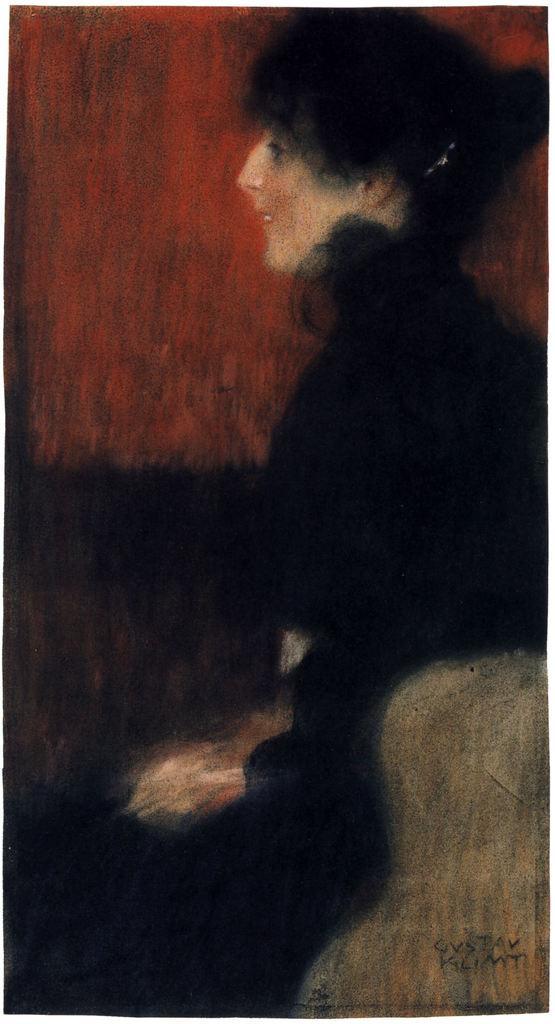Could you give a brief overview of what you see in this image? In this picture there is a painting of a woman and she is wearing black clothes. 